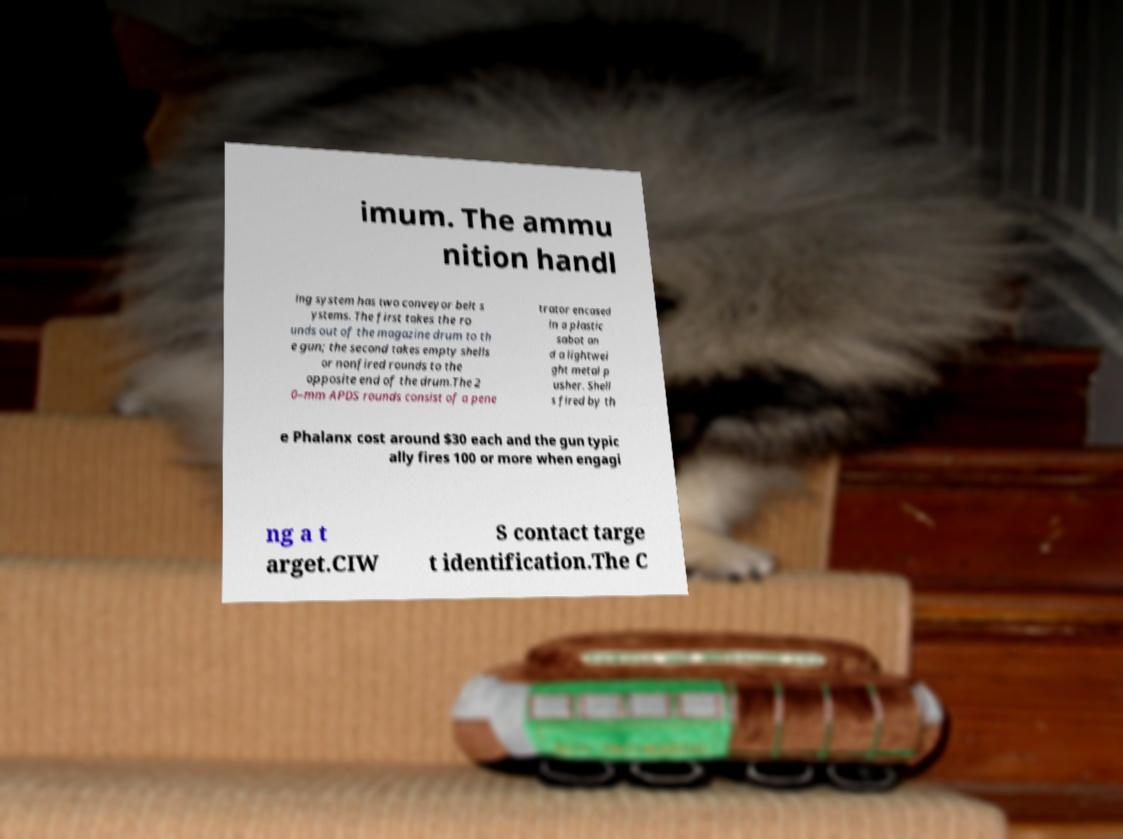Could you assist in decoding the text presented in this image and type it out clearly? imum. The ammu nition handl ing system has two conveyor belt s ystems. The first takes the ro unds out of the magazine drum to th e gun; the second takes empty shells or nonfired rounds to the opposite end of the drum.The 2 0–mm APDS rounds consist of a pene trator encased in a plastic sabot an d a lightwei ght metal p usher. Shell s fired by th e Phalanx cost around $30 each and the gun typic ally fires 100 or more when engagi ng a t arget.CIW S contact targe t identification.The C 